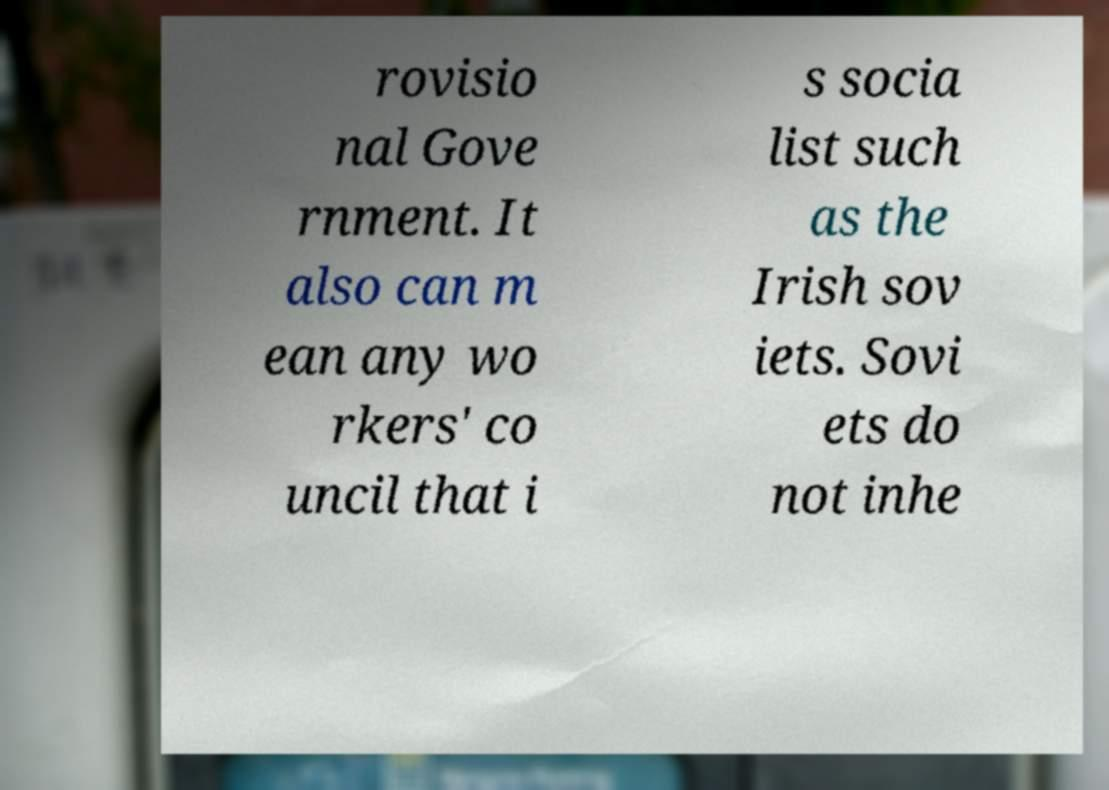What messages or text are displayed in this image? I need them in a readable, typed format. rovisio nal Gove rnment. It also can m ean any wo rkers' co uncil that i s socia list such as the Irish sov iets. Sovi ets do not inhe 